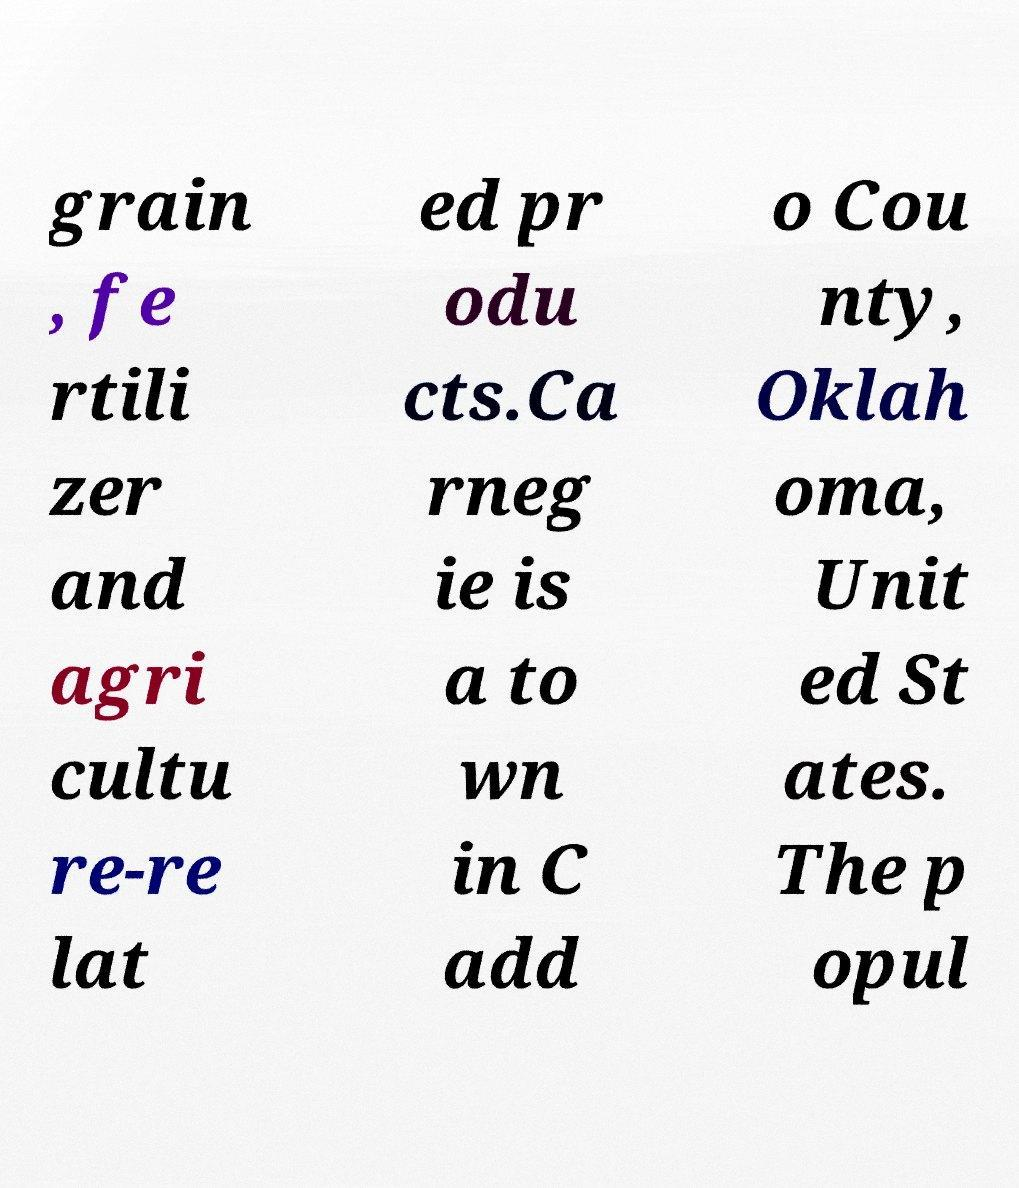Please identify and transcribe the text found in this image. grain , fe rtili zer and agri cultu re-re lat ed pr odu cts.Ca rneg ie is a to wn in C add o Cou nty, Oklah oma, Unit ed St ates. The p opul 